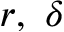<formula> <loc_0><loc_0><loc_500><loc_500>r , \delta</formula> 